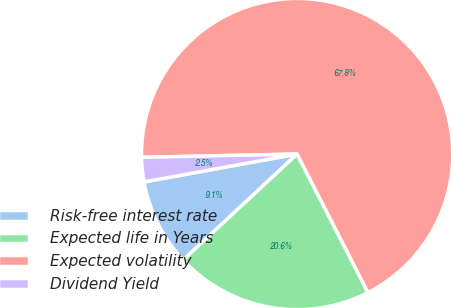Convert chart. <chart><loc_0><loc_0><loc_500><loc_500><pie_chart><fcel>Risk-free interest rate<fcel>Expected life in Years<fcel>Expected volatility<fcel>Dividend Yield<nl><fcel>9.06%<fcel>20.6%<fcel>67.81%<fcel>2.53%<nl></chart> 